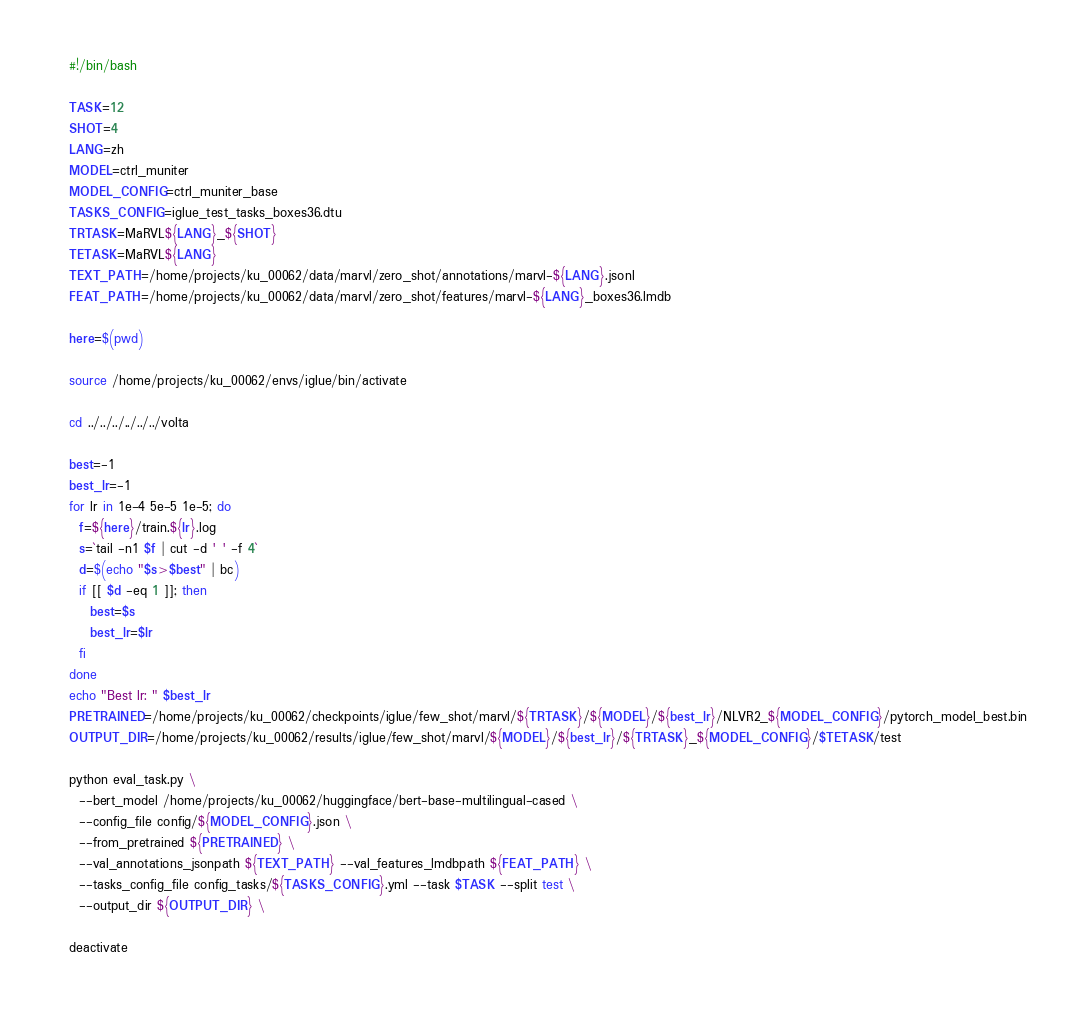<code> <loc_0><loc_0><loc_500><loc_500><_Bash_>#!/bin/bash

TASK=12
SHOT=4
LANG=zh
MODEL=ctrl_muniter
MODEL_CONFIG=ctrl_muniter_base
TASKS_CONFIG=iglue_test_tasks_boxes36.dtu
TRTASK=MaRVL${LANG}_${SHOT}
TETASK=MaRVL${LANG}
TEXT_PATH=/home/projects/ku_00062/data/marvl/zero_shot/annotations/marvl-${LANG}.jsonl
FEAT_PATH=/home/projects/ku_00062/data/marvl/zero_shot/features/marvl-${LANG}_boxes36.lmdb

here=$(pwd)

source /home/projects/ku_00062/envs/iglue/bin/activate

cd ../../../../../../volta

best=-1
best_lr=-1
for lr in 1e-4 5e-5 1e-5; do
  f=${here}/train.${lr}.log
  s=`tail -n1 $f | cut -d ' ' -f 4`
  d=$(echo "$s>$best" | bc)
  if [[ $d -eq 1 ]]; then
    best=$s
    best_lr=$lr
  fi
done
echo "Best lr: " $best_lr
PRETRAINED=/home/projects/ku_00062/checkpoints/iglue/few_shot/marvl/${TRTASK}/${MODEL}/${best_lr}/NLVR2_${MODEL_CONFIG}/pytorch_model_best.bin
OUTPUT_DIR=/home/projects/ku_00062/results/iglue/few_shot/marvl/${MODEL}/${best_lr}/${TRTASK}_${MODEL_CONFIG}/$TETASK/test

python eval_task.py \
  --bert_model /home/projects/ku_00062/huggingface/bert-base-multilingual-cased \
  --config_file config/${MODEL_CONFIG}.json \
  --from_pretrained ${PRETRAINED} \
  --val_annotations_jsonpath ${TEXT_PATH} --val_features_lmdbpath ${FEAT_PATH} \
  --tasks_config_file config_tasks/${TASKS_CONFIG}.yml --task $TASK --split test \
  --output_dir ${OUTPUT_DIR} \

deactivate
</code> 